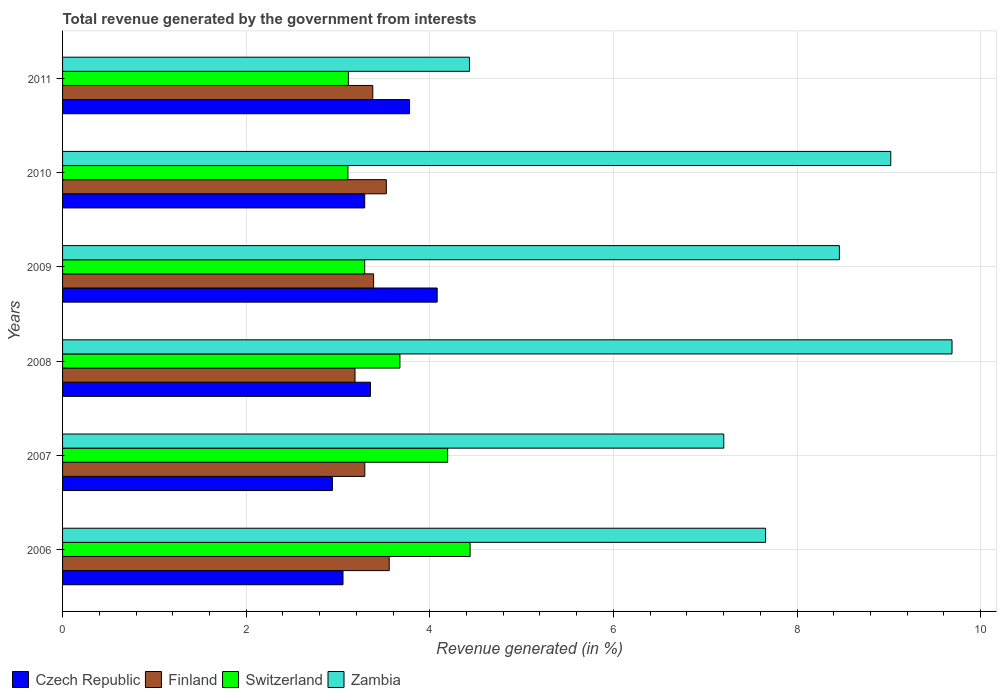How many different coloured bars are there?
Make the answer very short. 4. How many groups of bars are there?
Ensure brevity in your answer.  6. Are the number of bars per tick equal to the number of legend labels?
Your answer should be compact. Yes. What is the label of the 6th group of bars from the top?
Offer a terse response. 2006. In how many cases, is the number of bars for a given year not equal to the number of legend labels?
Provide a succinct answer. 0. What is the total revenue generated in Finland in 2011?
Offer a terse response. 3.38. Across all years, what is the maximum total revenue generated in Czech Republic?
Provide a succinct answer. 4.08. Across all years, what is the minimum total revenue generated in Zambia?
Ensure brevity in your answer.  4.43. In which year was the total revenue generated in Switzerland maximum?
Your response must be concise. 2006. What is the total total revenue generated in Finland in the graph?
Give a very brief answer. 20.33. What is the difference between the total revenue generated in Switzerland in 2007 and that in 2011?
Keep it short and to the point. 1.08. What is the difference between the total revenue generated in Czech Republic in 2009 and the total revenue generated in Switzerland in 2008?
Ensure brevity in your answer.  0.41. What is the average total revenue generated in Switzerland per year?
Make the answer very short. 3.64. In the year 2010, what is the difference between the total revenue generated in Switzerland and total revenue generated in Czech Republic?
Offer a terse response. -0.18. What is the ratio of the total revenue generated in Switzerland in 2008 to that in 2010?
Provide a succinct answer. 1.18. Is the difference between the total revenue generated in Switzerland in 2007 and 2011 greater than the difference between the total revenue generated in Czech Republic in 2007 and 2011?
Give a very brief answer. Yes. What is the difference between the highest and the second highest total revenue generated in Czech Republic?
Your answer should be compact. 0.3. What is the difference between the highest and the lowest total revenue generated in Finland?
Your response must be concise. 0.37. In how many years, is the total revenue generated in Zambia greater than the average total revenue generated in Zambia taken over all years?
Keep it short and to the point. 3. What does the 1st bar from the top in 2011 represents?
Keep it short and to the point. Zambia. What does the 1st bar from the bottom in 2006 represents?
Ensure brevity in your answer.  Czech Republic. How many bars are there?
Your answer should be compact. 24. How many years are there in the graph?
Your response must be concise. 6. What is the difference between two consecutive major ticks on the X-axis?
Give a very brief answer. 2. Does the graph contain grids?
Ensure brevity in your answer.  Yes. How many legend labels are there?
Keep it short and to the point. 4. How are the legend labels stacked?
Keep it short and to the point. Horizontal. What is the title of the graph?
Provide a short and direct response. Total revenue generated by the government from interests. Does "Madagascar" appear as one of the legend labels in the graph?
Make the answer very short. No. What is the label or title of the X-axis?
Offer a terse response. Revenue generated (in %). What is the label or title of the Y-axis?
Offer a very short reply. Years. What is the Revenue generated (in %) of Czech Republic in 2006?
Your answer should be compact. 3.05. What is the Revenue generated (in %) in Finland in 2006?
Offer a terse response. 3.56. What is the Revenue generated (in %) of Switzerland in 2006?
Give a very brief answer. 4.44. What is the Revenue generated (in %) in Zambia in 2006?
Provide a succinct answer. 7.66. What is the Revenue generated (in %) of Czech Republic in 2007?
Make the answer very short. 2.94. What is the Revenue generated (in %) of Finland in 2007?
Provide a short and direct response. 3.29. What is the Revenue generated (in %) in Switzerland in 2007?
Your answer should be very brief. 4.19. What is the Revenue generated (in %) of Zambia in 2007?
Your response must be concise. 7.2. What is the Revenue generated (in %) of Czech Republic in 2008?
Keep it short and to the point. 3.35. What is the Revenue generated (in %) of Finland in 2008?
Provide a succinct answer. 3.19. What is the Revenue generated (in %) in Switzerland in 2008?
Make the answer very short. 3.67. What is the Revenue generated (in %) in Zambia in 2008?
Your answer should be very brief. 9.69. What is the Revenue generated (in %) in Czech Republic in 2009?
Provide a succinct answer. 4.08. What is the Revenue generated (in %) of Finland in 2009?
Ensure brevity in your answer.  3.39. What is the Revenue generated (in %) in Switzerland in 2009?
Your response must be concise. 3.29. What is the Revenue generated (in %) of Zambia in 2009?
Keep it short and to the point. 8.46. What is the Revenue generated (in %) of Czech Republic in 2010?
Make the answer very short. 3.29. What is the Revenue generated (in %) in Finland in 2010?
Give a very brief answer. 3.53. What is the Revenue generated (in %) in Switzerland in 2010?
Ensure brevity in your answer.  3.11. What is the Revenue generated (in %) in Zambia in 2010?
Your answer should be very brief. 9.02. What is the Revenue generated (in %) of Czech Republic in 2011?
Give a very brief answer. 3.78. What is the Revenue generated (in %) in Finland in 2011?
Make the answer very short. 3.38. What is the Revenue generated (in %) of Switzerland in 2011?
Make the answer very short. 3.11. What is the Revenue generated (in %) in Zambia in 2011?
Offer a terse response. 4.43. Across all years, what is the maximum Revenue generated (in %) of Czech Republic?
Provide a short and direct response. 4.08. Across all years, what is the maximum Revenue generated (in %) in Finland?
Give a very brief answer. 3.56. Across all years, what is the maximum Revenue generated (in %) in Switzerland?
Make the answer very short. 4.44. Across all years, what is the maximum Revenue generated (in %) of Zambia?
Provide a short and direct response. 9.69. Across all years, what is the minimum Revenue generated (in %) in Czech Republic?
Your answer should be very brief. 2.94. Across all years, what is the minimum Revenue generated (in %) in Finland?
Give a very brief answer. 3.19. Across all years, what is the minimum Revenue generated (in %) of Switzerland?
Ensure brevity in your answer.  3.11. Across all years, what is the minimum Revenue generated (in %) of Zambia?
Your answer should be compact. 4.43. What is the total Revenue generated (in %) in Czech Republic in the graph?
Offer a terse response. 20.5. What is the total Revenue generated (in %) of Finland in the graph?
Give a very brief answer. 20.33. What is the total Revenue generated (in %) of Switzerland in the graph?
Your answer should be very brief. 21.82. What is the total Revenue generated (in %) of Zambia in the graph?
Offer a very short reply. 46.46. What is the difference between the Revenue generated (in %) of Czech Republic in 2006 and that in 2007?
Offer a very short reply. 0.12. What is the difference between the Revenue generated (in %) of Finland in 2006 and that in 2007?
Keep it short and to the point. 0.27. What is the difference between the Revenue generated (in %) in Switzerland in 2006 and that in 2007?
Your answer should be compact. 0.24. What is the difference between the Revenue generated (in %) of Zambia in 2006 and that in 2007?
Give a very brief answer. 0.46. What is the difference between the Revenue generated (in %) in Czech Republic in 2006 and that in 2008?
Give a very brief answer. -0.3. What is the difference between the Revenue generated (in %) of Finland in 2006 and that in 2008?
Your answer should be very brief. 0.37. What is the difference between the Revenue generated (in %) in Switzerland in 2006 and that in 2008?
Offer a terse response. 0.76. What is the difference between the Revenue generated (in %) of Zambia in 2006 and that in 2008?
Your answer should be compact. -2.03. What is the difference between the Revenue generated (in %) of Czech Republic in 2006 and that in 2009?
Offer a terse response. -1.03. What is the difference between the Revenue generated (in %) in Finland in 2006 and that in 2009?
Your answer should be compact. 0.17. What is the difference between the Revenue generated (in %) in Switzerland in 2006 and that in 2009?
Your answer should be very brief. 1.15. What is the difference between the Revenue generated (in %) of Zambia in 2006 and that in 2009?
Your answer should be compact. -0.8. What is the difference between the Revenue generated (in %) of Czech Republic in 2006 and that in 2010?
Make the answer very short. -0.24. What is the difference between the Revenue generated (in %) in Finland in 2006 and that in 2010?
Your answer should be compact. 0.03. What is the difference between the Revenue generated (in %) of Switzerland in 2006 and that in 2010?
Offer a terse response. 1.33. What is the difference between the Revenue generated (in %) of Zambia in 2006 and that in 2010?
Make the answer very short. -1.36. What is the difference between the Revenue generated (in %) in Czech Republic in 2006 and that in 2011?
Provide a short and direct response. -0.72. What is the difference between the Revenue generated (in %) of Finland in 2006 and that in 2011?
Your answer should be compact. 0.18. What is the difference between the Revenue generated (in %) of Switzerland in 2006 and that in 2011?
Your answer should be very brief. 1.33. What is the difference between the Revenue generated (in %) in Zambia in 2006 and that in 2011?
Offer a very short reply. 3.23. What is the difference between the Revenue generated (in %) in Czech Republic in 2007 and that in 2008?
Provide a succinct answer. -0.42. What is the difference between the Revenue generated (in %) in Finland in 2007 and that in 2008?
Provide a succinct answer. 0.11. What is the difference between the Revenue generated (in %) in Switzerland in 2007 and that in 2008?
Keep it short and to the point. 0.52. What is the difference between the Revenue generated (in %) of Zambia in 2007 and that in 2008?
Ensure brevity in your answer.  -2.49. What is the difference between the Revenue generated (in %) in Czech Republic in 2007 and that in 2009?
Your response must be concise. -1.14. What is the difference between the Revenue generated (in %) of Finland in 2007 and that in 2009?
Give a very brief answer. -0.1. What is the difference between the Revenue generated (in %) in Switzerland in 2007 and that in 2009?
Make the answer very short. 0.9. What is the difference between the Revenue generated (in %) of Zambia in 2007 and that in 2009?
Your answer should be compact. -1.26. What is the difference between the Revenue generated (in %) in Czech Republic in 2007 and that in 2010?
Provide a succinct answer. -0.35. What is the difference between the Revenue generated (in %) in Finland in 2007 and that in 2010?
Provide a short and direct response. -0.23. What is the difference between the Revenue generated (in %) in Switzerland in 2007 and that in 2010?
Provide a succinct answer. 1.09. What is the difference between the Revenue generated (in %) in Zambia in 2007 and that in 2010?
Provide a short and direct response. -1.82. What is the difference between the Revenue generated (in %) in Czech Republic in 2007 and that in 2011?
Your answer should be very brief. -0.84. What is the difference between the Revenue generated (in %) in Finland in 2007 and that in 2011?
Keep it short and to the point. -0.09. What is the difference between the Revenue generated (in %) of Switzerland in 2007 and that in 2011?
Ensure brevity in your answer.  1.08. What is the difference between the Revenue generated (in %) of Zambia in 2007 and that in 2011?
Your response must be concise. 2.77. What is the difference between the Revenue generated (in %) in Czech Republic in 2008 and that in 2009?
Provide a succinct answer. -0.73. What is the difference between the Revenue generated (in %) in Finland in 2008 and that in 2009?
Ensure brevity in your answer.  -0.2. What is the difference between the Revenue generated (in %) of Switzerland in 2008 and that in 2009?
Offer a very short reply. 0.38. What is the difference between the Revenue generated (in %) in Zambia in 2008 and that in 2009?
Your response must be concise. 1.23. What is the difference between the Revenue generated (in %) of Czech Republic in 2008 and that in 2010?
Keep it short and to the point. 0.06. What is the difference between the Revenue generated (in %) of Finland in 2008 and that in 2010?
Your answer should be compact. -0.34. What is the difference between the Revenue generated (in %) of Switzerland in 2008 and that in 2010?
Provide a succinct answer. 0.57. What is the difference between the Revenue generated (in %) of Zambia in 2008 and that in 2010?
Keep it short and to the point. 0.67. What is the difference between the Revenue generated (in %) of Czech Republic in 2008 and that in 2011?
Keep it short and to the point. -0.43. What is the difference between the Revenue generated (in %) in Finland in 2008 and that in 2011?
Provide a succinct answer. -0.19. What is the difference between the Revenue generated (in %) in Switzerland in 2008 and that in 2011?
Your answer should be very brief. 0.56. What is the difference between the Revenue generated (in %) in Zambia in 2008 and that in 2011?
Your response must be concise. 5.26. What is the difference between the Revenue generated (in %) of Czech Republic in 2009 and that in 2010?
Make the answer very short. 0.79. What is the difference between the Revenue generated (in %) in Finland in 2009 and that in 2010?
Provide a short and direct response. -0.14. What is the difference between the Revenue generated (in %) in Switzerland in 2009 and that in 2010?
Your answer should be very brief. 0.18. What is the difference between the Revenue generated (in %) of Zambia in 2009 and that in 2010?
Keep it short and to the point. -0.56. What is the difference between the Revenue generated (in %) in Czech Republic in 2009 and that in 2011?
Offer a very short reply. 0.3. What is the difference between the Revenue generated (in %) in Finland in 2009 and that in 2011?
Your answer should be compact. 0.01. What is the difference between the Revenue generated (in %) in Switzerland in 2009 and that in 2011?
Offer a terse response. 0.18. What is the difference between the Revenue generated (in %) of Zambia in 2009 and that in 2011?
Your response must be concise. 4.03. What is the difference between the Revenue generated (in %) of Czech Republic in 2010 and that in 2011?
Provide a succinct answer. -0.49. What is the difference between the Revenue generated (in %) of Finland in 2010 and that in 2011?
Ensure brevity in your answer.  0.15. What is the difference between the Revenue generated (in %) of Switzerland in 2010 and that in 2011?
Offer a very short reply. -0.01. What is the difference between the Revenue generated (in %) of Zambia in 2010 and that in 2011?
Your response must be concise. 4.59. What is the difference between the Revenue generated (in %) of Czech Republic in 2006 and the Revenue generated (in %) of Finland in 2007?
Provide a short and direct response. -0.24. What is the difference between the Revenue generated (in %) of Czech Republic in 2006 and the Revenue generated (in %) of Switzerland in 2007?
Provide a succinct answer. -1.14. What is the difference between the Revenue generated (in %) in Czech Republic in 2006 and the Revenue generated (in %) in Zambia in 2007?
Give a very brief answer. -4.15. What is the difference between the Revenue generated (in %) of Finland in 2006 and the Revenue generated (in %) of Switzerland in 2007?
Give a very brief answer. -0.64. What is the difference between the Revenue generated (in %) in Finland in 2006 and the Revenue generated (in %) in Zambia in 2007?
Your answer should be compact. -3.64. What is the difference between the Revenue generated (in %) in Switzerland in 2006 and the Revenue generated (in %) in Zambia in 2007?
Keep it short and to the point. -2.76. What is the difference between the Revenue generated (in %) of Czech Republic in 2006 and the Revenue generated (in %) of Finland in 2008?
Give a very brief answer. -0.13. What is the difference between the Revenue generated (in %) in Czech Republic in 2006 and the Revenue generated (in %) in Switzerland in 2008?
Provide a short and direct response. -0.62. What is the difference between the Revenue generated (in %) of Czech Republic in 2006 and the Revenue generated (in %) of Zambia in 2008?
Provide a short and direct response. -6.63. What is the difference between the Revenue generated (in %) of Finland in 2006 and the Revenue generated (in %) of Switzerland in 2008?
Ensure brevity in your answer.  -0.12. What is the difference between the Revenue generated (in %) in Finland in 2006 and the Revenue generated (in %) in Zambia in 2008?
Offer a very short reply. -6.13. What is the difference between the Revenue generated (in %) in Switzerland in 2006 and the Revenue generated (in %) in Zambia in 2008?
Ensure brevity in your answer.  -5.25. What is the difference between the Revenue generated (in %) in Czech Republic in 2006 and the Revenue generated (in %) in Finland in 2009?
Make the answer very short. -0.33. What is the difference between the Revenue generated (in %) of Czech Republic in 2006 and the Revenue generated (in %) of Switzerland in 2009?
Offer a very short reply. -0.24. What is the difference between the Revenue generated (in %) in Czech Republic in 2006 and the Revenue generated (in %) in Zambia in 2009?
Make the answer very short. -5.41. What is the difference between the Revenue generated (in %) of Finland in 2006 and the Revenue generated (in %) of Switzerland in 2009?
Your answer should be compact. 0.27. What is the difference between the Revenue generated (in %) in Finland in 2006 and the Revenue generated (in %) in Zambia in 2009?
Offer a terse response. -4.9. What is the difference between the Revenue generated (in %) of Switzerland in 2006 and the Revenue generated (in %) of Zambia in 2009?
Provide a short and direct response. -4.02. What is the difference between the Revenue generated (in %) of Czech Republic in 2006 and the Revenue generated (in %) of Finland in 2010?
Make the answer very short. -0.47. What is the difference between the Revenue generated (in %) in Czech Republic in 2006 and the Revenue generated (in %) in Switzerland in 2010?
Make the answer very short. -0.05. What is the difference between the Revenue generated (in %) in Czech Republic in 2006 and the Revenue generated (in %) in Zambia in 2010?
Keep it short and to the point. -5.97. What is the difference between the Revenue generated (in %) in Finland in 2006 and the Revenue generated (in %) in Switzerland in 2010?
Offer a very short reply. 0.45. What is the difference between the Revenue generated (in %) of Finland in 2006 and the Revenue generated (in %) of Zambia in 2010?
Offer a very short reply. -5.46. What is the difference between the Revenue generated (in %) of Switzerland in 2006 and the Revenue generated (in %) of Zambia in 2010?
Provide a short and direct response. -4.58. What is the difference between the Revenue generated (in %) in Czech Republic in 2006 and the Revenue generated (in %) in Finland in 2011?
Your answer should be very brief. -0.32. What is the difference between the Revenue generated (in %) of Czech Republic in 2006 and the Revenue generated (in %) of Switzerland in 2011?
Keep it short and to the point. -0.06. What is the difference between the Revenue generated (in %) in Czech Republic in 2006 and the Revenue generated (in %) in Zambia in 2011?
Ensure brevity in your answer.  -1.38. What is the difference between the Revenue generated (in %) in Finland in 2006 and the Revenue generated (in %) in Switzerland in 2011?
Make the answer very short. 0.44. What is the difference between the Revenue generated (in %) of Finland in 2006 and the Revenue generated (in %) of Zambia in 2011?
Provide a succinct answer. -0.87. What is the difference between the Revenue generated (in %) in Switzerland in 2006 and the Revenue generated (in %) in Zambia in 2011?
Offer a very short reply. 0.01. What is the difference between the Revenue generated (in %) of Czech Republic in 2007 and the Revenue generated (in %) of Finland in 2008?
Your answer should be very brief. -0.25. What is the difference between the Revenue generated (in %) of Czech Republic in 2007 and the Revenue generated (in %) of Switzerland in 2008?
Your answer should be compact. -0.74. What is the difference between the Revenue generated (in %) in Czech Republic in 2007 and the Revenue generated (in %) in Zambia in 2008?
Keep it short and to the point. -6.75. What is the difference between the Revenue generated (in %) of Finland in 2007 and the Revenue generated (in %) of Switzerland in 2008?
Your answer should be very brief. -0.38. What is the difference between the Revenue generated (in %) of Finland in 2007 and the Revenue generated (in %) of Zambia in 2008?
Give a very brief answer. -6.4. What is the difference between the Revenue generated (in %) in Switzerland in 2007 and the Revenue generated (in %) in Zambia in 2008?
Offer a terse response. -5.49. What is the difference between the Revenue generated (in %) in Czech Republic in 2007 and the Revenue generated (in %) in Finland in 2009?
Your answer should be compact. -0.45. What is the difference between the Revenue generated (in %) in Czech Republic in 2007 and the Revenue generated (in %) in Switzerland in 2009?
Offer a very short reply. -0.35. What is the difference between the Revenue generated (in %) in Czech Republic in 2007 and the Revenue generated (in %) in Zambia in 2009?
Keep it short and to the point. -5.52. What is the difference between the Revenue generated (in %) of Finland in 2007 and the Revenue generated (in %) of Switzerland in 2009?
Ensure brevity in your answer.  0. What is the difference between the Revenue generated (in %) of Finland in 2007 and the Revenue generated (in %) of Zambia in 2009?
Provide a succinct answer. -5.17. What is the difference between the Revenue generated (in %) of Switzerland in 2007 and the Revenue generated (in %) of Zambia in 2009?
Offer a terse response. -4.27. What is the difference between the Revenue generated (in %) in Czech Republic in 2007 and the Revenue generated (in %) in Finland in 2010?
Offer a very short reply. -0.59. What is the difference between the Revenue generated (in %) of Czech Republic in 2007 and the Revenue generated (in %) of Switzerland in 2010?
Make the answer very short. -0.17. What is the difference between the Revenue generated (in %) of Czech Republic in 2007 and the Revenue generated (in %) of Zambia in 2010?
Your answer should be compact. -6.08. What is the difference between the Revenue generated (in %) in Finland in 2007 and the Revenue generated (in %) in Switzerland in 2010?
Give a very brief answer. 0.18. What is the difference between the Revenue generated (in %) in Finland in 2007 and the Revenue generated (in %) in Zambia in 2010?
Offer a terse response. -5.73. What is the difference between the Revenue generated (in %) of Switzerland in 2007 and the Revenue generated (in %) of Zambia in 2010?
Your answer should be compact. -4.83. What is the difference between the Revenue generated (in %) in Czech Republic in 2007 and the Revenue generated (in %) in Finland in 2011?
Your answer should be compact. -0.44. What is the difference between the Revenue generated (in %) in Czech Republic in 2007 and the Revenue generated (in %) in Switzerland in 2011?
Your answer should be compact. -0.17. What is the difference between the Revenue generated (in %) in Czech Republic in 2007 and the Revenue generated (in %) in Zambia in 2011?
Offer a terse response. -1.49. What is the difference between the Revenue generated (in %) in Finland in 2007 and the Revenue generated (in %) in Switzerland in 2011?
Your answer should be very brief. 0.18. What is the difference between the Revenue generated (in %) of Finland in 2007 and the Revenue generated (in %) of Zambia in 2011?
Provide a short and direct response. -1.14. What is the difference between the Revenue generated (in %) in Switzerland in 2007 and the Revenue generated (in %) in Zambia in 2011?
Your answer should be compact. -0.24. What is the difference between the Revenue generated (in %) in Czech Republic in 2008 and the Revenue generated (in %) in Finland in 2009?
Offer a terse response. -0.03. What is the difference between the Revenue generated (in %) of Czech Republic in 2008 and the Revenue generated (in %) of Switzerland in 2009?
Offer a very short reply. 0.06. What is the difference between the Revenue generated (in %) of Czech Republic in 2008 and the Revenue generated (in %) of Zambia in 2009?
Offer a terse response. -5.11. What is the difference between the Revenue generated (in %) of Finland in 2008 and the Revenue generated (in %) of Switzerland in 2009?
Give a very brief answer. -0.11. What is the difference between the Revenue generated (in %) of Finland in 2008 and the Revenue generated (in %) of Zambia in 2009?
Offer a very short reply. -5.28. What is the difference between the Revenue generated (in %) in Switzerland in 2008 and the Revenue generated (in %) in Zambia in 2009?
Offer a terse response. -4.79. What is the difference between the Revenue generated (in %) in Czech Republic in 2008 and the Revenue generated (in %) in Finland in 2010?
Give a very brief answer. -0.17. What is the difference between the Revenue generated (in %) in Czech Republic in 2008 and the Revenue generated (in %) in Switzerland in 2010?
Provide a short and direct response. 0.25. What is the difference between the Revenue generated (in %) in Czech Republic in 2008 and the Revenue generated (in %) in Zambia in 2010?
Offer a very short reply. -5.67. What is the difference between the Revenue generated (in %) of Finland in 2008 and the Revenue generated (in %) of Switzerland in 2010?
Provide a succinct answer. 0.08. What is the difference between the Revenue generated (in %) in Finland in 2008 and the Revenue generated (in %) in Zambia in 2010?
Provide a short and direct response. -5.84. What is the difference between the Revenue generated (in %) of Switzerland in 2008 and the Revenue generated (in %) of Zambia in 2010?
Provide a short and direct response. -5.35. What is the difference between the Revenue generated (in %) of Czech Republic in 2008 and the Revenue generated (in %) of Finland in 2011?
Make the answer very short. -0.02. What is the difference between the Revenue generated (in %) in Czech Republic in 2008 and the Revenue generated (in %) in Switzerland in 2011?
Give a very brief answer. 0.24. What is the difference between the Revenue generated (in %) of Czech Republic in 2008 and the Revenue generated (in %) of Zambia in 2011?
Your answer should be compact. -1.08. What is the difference between the Revenue generated (in %) in Finland in 2008 and the Revenue generated (in %) in Switzerland in 2011?
Your response must be concise. 0.07. What is the difference between the Revenue generated (in %) of Finland in 2008 and the Revenue generated (in %) of Zambia in 2011?
Offer a terse response. -1.25. What is the difference between the Revenue generated (in %) of Switzerland in 2008 and the Revenue generated (in %) of Zambia in 2011?
Your response must be concise. -0.76. What is the difference between the Revenue generated (in %) of Czech Republic in 2009 and the Revenue generated (in %) of Finland in 2010?
Your response must be concise. 0.55. What is the difference between the Revenue generated (in %) in Czech Republic in 2009 and the Revenue generated (in %) in Switzerland in 2010?
Ensure brevity in your answer.  0.97. What is the difference between the Revenue generated (in %) of Czech Republic in 2009 and the Revenue generated (in %) of Zambia in 2010?
Your answer should be very brief. -4.94. What is the difference between the Revenue generated (in %) in Finland in 2009 and the Revenue generated (in %) in Switzerland in 2010?
Provide a succinct answer. 0.28. What is the difference between the Revenue generated (in %) in Finland in 2009 and the Revenue generated (in %) in Zambia in 2010?
Your answer should be very brief. -5.63. What is the difference between the Revenue generated (in %) in Switzerland in 2009 and the Revenue generated (in %) in Zambia in 2010?
Your response must be concise. -5.73. What is the difference between the Revenue generated (in %) of Czech Republic in 2009 and the Revenue generated (in %) of Finland in 2011?
Your answer should be compact. 0.7. What is the difference between the Revenue generated (in %) in Czech Republic in 2009 and the Revenue generated (in %) in Switzerland in 2011?
Your response must be concise. 0.97. What is the difference between the Revenue generated (in %) of Czech Republic in 2009 and the Revenue generated (in %) of Zambia in 2011?
Offer a very short reply. -0.35. What is the difference between the Revenue generated (in %) of Finland in 2009 and the Revenue generated (in %) of Switzerland in 2011?
Keep it short and to the point. 0.27. What is the difference between the Revenue generated (in %) in Finland in 2009 and the Revenue generated (in %) in Zambia in 2011?
Make the answer very short. -1.04. What is the difference between the Revenue generated (in %) of Switzerland in 2009 and the Revenue generated (in %) of Zambia in 2011?
Provide a succinct answer. -1.14. What is the difference between the Revenue generated (in %) in Czech Republic in 2010 and the Revenue generated (in %) in Finland in 2011?
Your answer should be very brief. -0.09. What is the difference between the Revenue generated (in %) of Czech Republic in 2010 and the Revenue generated (in %) of Switzerland in 2011?
Offer a terse response. 0.18. What is the difference between the Revenue generated (in %) in Czech Republic in 2010 and the Revenue generated (in %) in Zambia in 2011?
Provide a short and direct response. -1.14. What is the difference between the Revenue generated (in %) in Finland in 2010 and the Revenue generated (in %) in Switzerland in 2011?
Provide a short and direct response. 0.41. What is the difference between the Revenue generated (in %) in Finland in 2010 and the Revenue generated (in %) in Zambia in 2011?
Give a very brief answer. -0.91. What is the difference between the Revenue generated (in %) of Switzerland in 2010 and the Revenue generated (in %) of Zambia in 2011?
Offer a terse response. -1.32. What is the average Revenue generated (in %) of Czech Republic per year?
Provide a succinct answer. 3.42. What is the average Revenue generated (in %) in Finland per year?
Your answer should be compact. 3.39. What is the average Revenue generated (in %) of Switzerland per year?
Offer a very short reply. 3.64. What is the average Revenue generated (in %) in Zambia per year?
Ensure brevity in your answer.  7.74. In the year 2006, what is the difference between the Revenue generated (in %) in Czech Republic and Revenue generated (in %) in Finland?
Ensure brevity in your answer.  -0.5. In the year 2006, what is the difference between the Revenue generated (in %) of Czech Republic and Revenue generated (in %) of Switzerland?
Offer a terse response. -1.38. In the year 2006, what is the difference between the Revenue generated (in %) of Czech Republic and Revenue generated (in %) of Zambia?
Ensure brevity in your answer.  -4.6. In the year 2006, what is the difference between the Revenue generated (in %) in Finland and Revenue generated (in %) in Switzerland?
Make the answer very short. -0.88. In the year 2006, what is the difference between the Revenue generated (in %) in Finland and Revenue generated (in %) in Zambia?
Keep it short and to the point. -4.1. In the year 2006, what is the difference between the Revenue generated (in %) in Switzerland and Revenue generated (in %) in Zambia?
Offer a terse response. -3.22. In the year 2007, what is the difference between the Revenue generated (in %) in Czech Republic and Revenue generated (in %) in Finland?
Make the answer very short. -0.35. In the year 2007, what is the difference between the Revenue generated (in %) in Czech Republic and Revenue generated (in %) in Switzerland?
Provide a short and direct response. -1.26. In the year 2007, what is the difference between the Revenue generated (in %) of Czech Republic and Revenue generated (in %) of Zambia?
Offer a very short reply. -4.26. In the year 2007, what is the difference between the Revenue generated (in %) in Finland and Revenue generated (in %) in Switzerland?
Provide a short and direct response. -0.9. In the year 2007, what is the difference between the Revenue generated (in %) of Finland and Revenue generated (in %) of Zambia?
Your response must be concise. -3.91. In the year 2007, what is the difference between the Revenue generated (in %) of Switzerland and Revenue generated (in %) of Zambia?
Provide a succinct answer. -3.01. In the year 2008, what is the difference between the Revenue generated (in %) of Czech Republic and Revenue generated (in %) of Finland?
Ensure brevity in your answer.  0.17. In the year 2008, what is the difference between the Revenue generated (in %) of Czech Republic and Revenue generated (in %) of Switzerland?
Provide a short and direct response. -0.32. In the year 2008, what is the difference between the Revenue generated (in %) of Czech Republic and Revenue generated (in %) of Zambia?
Your answer should be very brief. -6.33. In the year 2008, what is the difference between the Revenue generated (in %) of Finland and Revenue generated (in %) of Switzerland?
Your answer should be compact. -0.49. In the year 2008, what is the difference between the Revenue generated (in %) in Finland and Revenue generated (in %) in Zambia?
Your answer should be very brief. -6.5. In the year 2008, what is the difference between the Revenue generated (in %) of Switzerland and Revenue generated (in %) of Zambia?
Your answer should be compact. -6.01. In the year 2009, what is the difference between the Revenue generated (in %) of Czech Republic and Revenue generated (in %) of Finland?
Give a very brief answer. 0.69. In the year 2009, what is the difference between the Revenue generated (in %) in Czech Republic and Revenue generated (in %) in Switzerland?
Ensure brevity in your answer.  0.79. In the year 2009, what is the difference between the Revenue generated (in %) in Czech Republic and Revenue generated (in %) in Zambia?
Give a very brief answer. -4.38. In the year 2009, what is the difference between the Revenue generated (in %) in Finland and Revenue generated (in %) in Switzerland?
Your answer should be compact. 0.1. In the year 2009, what is the difference between the Revenue generated (in %) of Finland and Revenue generated (in %) of Zambia?
Make the answer very short. -5.07. In the year 2009, what is the difference between the Revenue generated (in %) of Switzerland and Revenue generated (in %) of Zambia?
Your response must be concise. -5.17. In the year 2010, what is the difference between the Revenue generated (in %) in Czech Republic and Revenue generated (in %) in Finland?
Give a very brief answer. -0.24. In the year 2010, what is the difference between the Revenue generated (in %) in Czech Republic and Revenue generated (in %) in Switzerland?
Keep it short and to the point. 0.18. In the year 2010, what is the difference between the Revenue generated (in %) in Czech Republic and Revenue generated (in %) in Zambia?
Offer a terse response. -5.73. In the year 2010, what is the difference between the Revenue generated (in %) of Finland and Revenue generated (in %) of Switzerland?
Keep it short and to the point. 0.42. In the year 2010, what is the difference between the Revenue generated (in %) of Finland and Revenue generated (in %) of Zambia?
Offer a very short reply. -5.49. In the year 2010, what is the difference between the Revenue generated (in %) in Switzerland and Revenue generated (in %) in Zambia?
Provide a succinct answer. -5.91. In the year 2011, what is the difference between the Revenue generated (in %) in Czech Republic and Revenue generated (in %) in Finland?
Provide a short and direct response. 0.4. In the year 2011, what is the difference between the Revenue generated (in %) of Czech Republic and Revenue generated (in %) of Switzerland?
Offer a very short reply. 0.67. In the year 2011, what is the difference between the Revenue generated (in %) in Czech Republic and Revenue generated (in %) in Zambia?
Give a very brief answer. -0.65. In the year 2011, what is the difference between the Revenue generated (in %) of Finland and Revenue generated (in %) of Switzerland?
Your response must be concise. 0.27. In the year 2011, what is the difference between the Revenue generated (in %) of Finland and Revenue generated (in %) of Zambia?
Make the answer very short. -1.05. In the year 2011, what is the difference between the Revenue generated (in %) in Switzerland and Revenue generated (in %) in Zambia?
Provide a short and direct response. -1.32. What is the ratio of the Revenue generated (in %) in Czech Republic in 2006 to that in 2007?
Offer a very short reply. 1.04. What is the ratio of the Revenue generated (in %) of Finland in 2006 to that in 2007?
Your response must be concise. 1.08. What is the ratio of the Revenue generated (in %) of Switzerland in 2006 to that in 2007?
Your answer should be very brief. 1.06. What is the ratio of the Revenue generated (in %) of Zambia in 2006 to that in 2007?
Your answer should be very brief. 1.06. What is the ratio of the Revenue generated (in %) in Czech Republic in 2006 to that in 2008?
Offer a very short reply. 0.91. What is the ratio of the Revenue generated (in %) of Finland in 2006 to that in 2008?
Offer a very short reply. 1.12. What is the ratio of the Revenue generated (in %) in Switzerland in 2006 to that in 2008?
Provide a short and direct response. 1.21. What is the ratio of the Revenue generated (in %) of Zambia in 2006 to that in 2008?
Offer a very short reply. 0.79. What is the ratio of the Revenue generated (in %) of Czech Republic in 2006 to that in 2009?
Offer a very short reply. 0.75. What is the ratio of the Revenue generated (in %) in Finland in 2006 to that in 2009?
Give a very brief answer. 1.05. What is the ratio of the Revenue generated (in %) in Switzerland in 2006 to that in 2009?
Offer a very short reply. 1.35. What is the ratio of the Revenue generated (in %) in Zambia in 2006 to that in 2009?
Provide a succinct answer. 0.91. What is the ratio of the Revenue generated (in %) of Czech Republic in 2006 to that in 2010?
Provide a succinct answer. 0.93. What is the ratio of the Revenue generated (in %) in Finland in 2006 to that in 2010?
Ensure brevity in your answer.  1.01. What is the ratio of the Revenue generated (in %) of Switzerland in 2006 to that in 2010?
Offer a very short reply. 1.43. What is the ratio of the Revenue generated (in %) of Zambia in 2006 to that in 2010?
Ensure brevity in your answer.  0.85. What is the ratio of the Revenue generated (in %) of Czech Republic in 2006 to that in 2011?
Your answer should be very brief. 0.81. What is the ratio of the Revenue generated (in %) of Finland in 2006 to that in 2011?
Your answer should be very brief. 1.05. What is the ratio of the Revenue generated (in %) in Switzerland in 2006 to that in 2011?
Offer a very short reply. 1.43. What is the ratio of the Revenue generated (in %) of Zambia in 2006 to that in 2011?
Provide a succinct answer. 1.73. What is the ratio of the Revenue generated (in %) in Czech Republic in 2007 to that in 2008?
Keep it short and to the point. 0.88. What is the ratio of the Revenue generated (in %) of Finland in 2007 to that in 2008?
Ensure brevity in your answer.  1.03. What is the ratio of the Revenue generated (in %) in Switzerland in 2007 to that in 2008?
Your response must be concise. 1.14. What is the ratio of the Revenue generated (in %) of Zambia in 2007 to that in 2008?
Ensure brevity in your answer.  0.74. What is the ratio of the Revenue generated (in %) of Czech Republic in 2007 to that in 2009?
Your answer should be very brief. 0.72. What is the ratio of the Revenue generated (in %) in Finland in 2007 to that in 2009?
Make the answer very short. 0.97. What is the ratio of the Revenue generated (in %) of Switzerland in 2007 to that in 2009?
Ensure brevity in your answer.  1.27. What is the ratio of the Revenue generated (in %) of Zambia in 2007 to that in 2009?
Give a very brief answer. 0.85. What is the ratio of the Revenue generated (in %) in Czech Republic in 2007 to that in 2010?
Offer a very short reply. 0.89. What is the ratio of the Revenue generated (in %) of Finland in 2007 to that in 2010?
Your answer should be compact. 0.93. What is the ratio of the Revenue generated (in %) in Switzerland in 2007 to that in 2010?
Provide a short and direct response. 1.35. What is the ratio of the Revenue generated (in %) in Zambia in 2007 to that in 2010?
Ensure brevity in your answer.  0.8. What is the ratio of the Revenue generated (in %) of Czech Republic in 2007 to that in 2011?
Your answer should be very brief. 0.78. What is the ratio of the Revenue generated (in %) in Finland in 2007 to that in 2011?
Your response must be concise. 0.97. What is the ratio of the Revenue generated (in %) in Switzerland in 2007 to that in 2011?
Ensure brevity in your answer.  1.35. What is the ratio of the Revenue generated (in %) of Zambia in 2007 to that in 2011?
Your response must be concise. 1.62. What is the ratio of the Revenue generated (in %) in Czech Republic in 2008 to that in 2009?
Your answer should be compact. 0.82. What is the ratio of the Revenue generated (in %) of Finland in 2008 to that in 2009?
Keep it short and to the point. 0.94. What is the ratio of the Revenue generated (in %) in Switzerland in 2008 to that in 2009?
Ensure brevity in your answer.  1.12. What is the ratio of the Revenue generated (in %) of Zambia in 2008 to that in 2009?
Keep it short and to the point. 1.15. What is the ratio of the Revenue generated (in %) of Czech Republic in 2008 to that in 2010?
Ensure brevity in your answer.  1.02. What is the ratio of the Revenue generated (in %) of Finland in 2008 to that in 2010?
Offer a terse response. 0.9. What is the ratio of the Revenue generated (in %) of Switzerland in 2008 to that in 2010?
Your answer should be compact. 1.18. What is the ratio of the Revenue generated (in %) of Zambia in 2008 to that in 2010?
Your response must be concise. 1.07. What is the ratio of the Revenue generated (in %) in Czech Republic in 2008 to that in 2011?
Give a very brief answer. 0.89. What is the ratio of the Revenue generated (in %) of Finland in 2008 to that in 2011?
Offer a very short reply. 0.94. What is the ratio of the Revenue generated (in %) of Switzerland in 2008 to that in 2011?
Offer a very short reply. 1.18. What is the ratio of the Revenue generated (in %) in Zambia in 2008 to that in 2011?
Make the answer very short. 2.19. What is the ratio of the Revenue generated (in %) of Czech Republic in 2009 to that in 2010?
Provide a succinct answer. 1.24. What is the ratio of the Revenue generated (in %) of Finland in 2009 to that in 2010?
Your response must be concise. 0.96. What is the ratio of the Revenue generated (in %) of Switzerland in 2009 to that in 2010?
Offer a terse response. 1.06. What is the ratio of the Revenue generated (in %) of Zambia in 2009 to that in 2010?
Give a very brief answer. 0.94. What is the ratio of the Revenue generated (in %) of Czech Republic in 2009 to that in 2011?
Give a very brief answer. 1.08. What is the ratio of the Revenue generated (in %) in Switzerland in 2009 to that in 2011?
Offer a terse response. 1.06. What is the ratio of the Revenue generated (in %) of Zambia in 2009 to that in 2011?
Provide a succinct answer. 1.91. What is the ratio of the Revenue generated (in %) of Czech Republic in 2010 to that in 2011?
Make the answer very short. 0.87. What is the ratio of the Revenue generated (in %) in Finland in 2010 to that in 2011?
Your answer should be compact. 1.04. What is the ratio of the Revenue generated (in %) of Zambia in 2010 to that in 2011?
Offer a terse response. 2.04. What is the difference between the highest and the second highest Revenue generated (in %) in Czech Republic?
Keep it short and to the point. 0.3. What is the difference between the highest and the second highest Revenue generated (in %) in Finland?
Make the answer very short. 0.03. What is the difference between the highest and the second highest Revenue generated (in %) in Switzerland?
Give a very brief answer. 0.24. What is the difference between the highest and the second highest Revenue generated (in %) in Zambia?
Offer a terse response. 0.67. What is the difference between the highest and the lowest Revenue generated (in %) in Czech Republic?
Your response must be concise. 1.14. What is the difference between the highest and the lowest Revenue generated (in %) in Finland?
Offer a very short reply. 0.37. What is the difference between the highest and the lowest Revenue generated (in %) in Switzerland?
Offer a terse response. 1.33. What is the difference between the highest and the lowest Revenue generated (in %) of Zambia?
Make the answer very short. 5.26. 